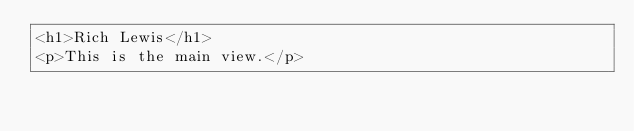Convert code to text. <code><loc_0><loc_0><loc_500><loc_500><_HTML_><h1>Rich Lewis</h1>
<p>This is the main view.</p></code> 